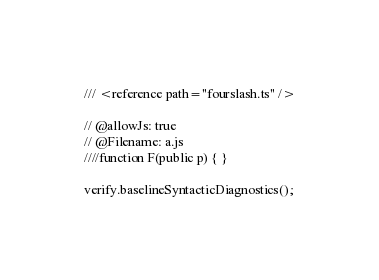<code> <loc_0><loc_0><loc_500><loc_500><_TypeScript_>/// <reference path="fourslash.ts" />

// @allowJs: true
// @Filename: a.js
////function F(public p) { }

verify.baselineSyntacticDiagnostics();
</code> 